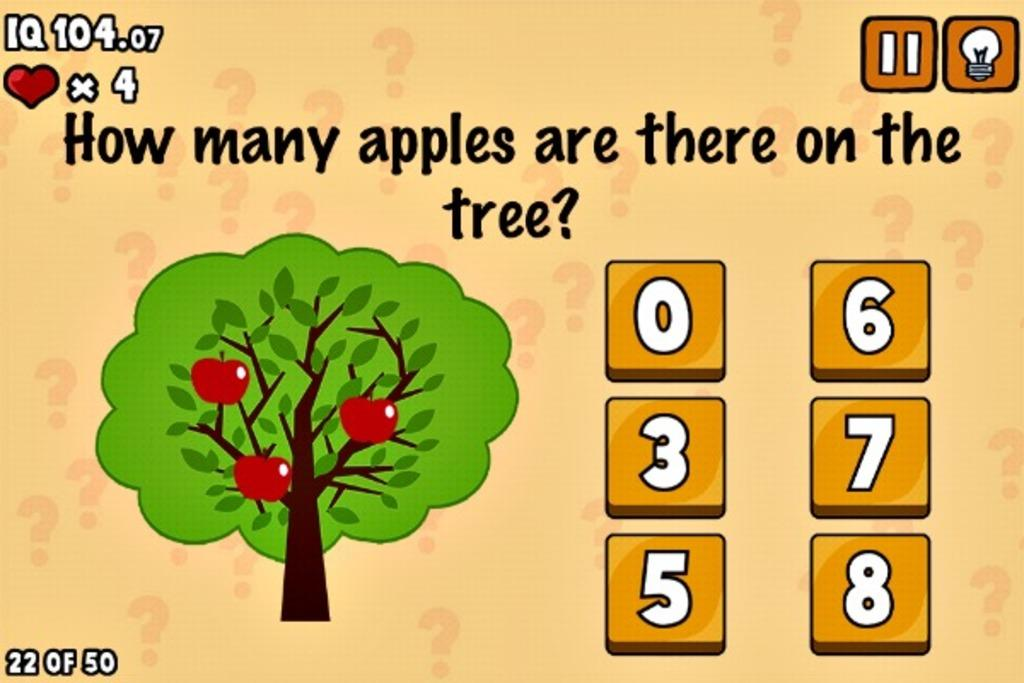What type of image is being described? The image is an animated screenshot. What can be seen in the image besides the animation? There are numbers, text, a tree, apples, and other objects in the image. Can you describe the tree in the image? There is a tree in the image. What is the relationship between the apples and the tree in the image? The apples are on or near the tree in the image. How many times did the tree crack during the birth of the apples in the image? There is no mention of the tree cracking or the apples being born in the image. The tree and apples are simply present in the image. 